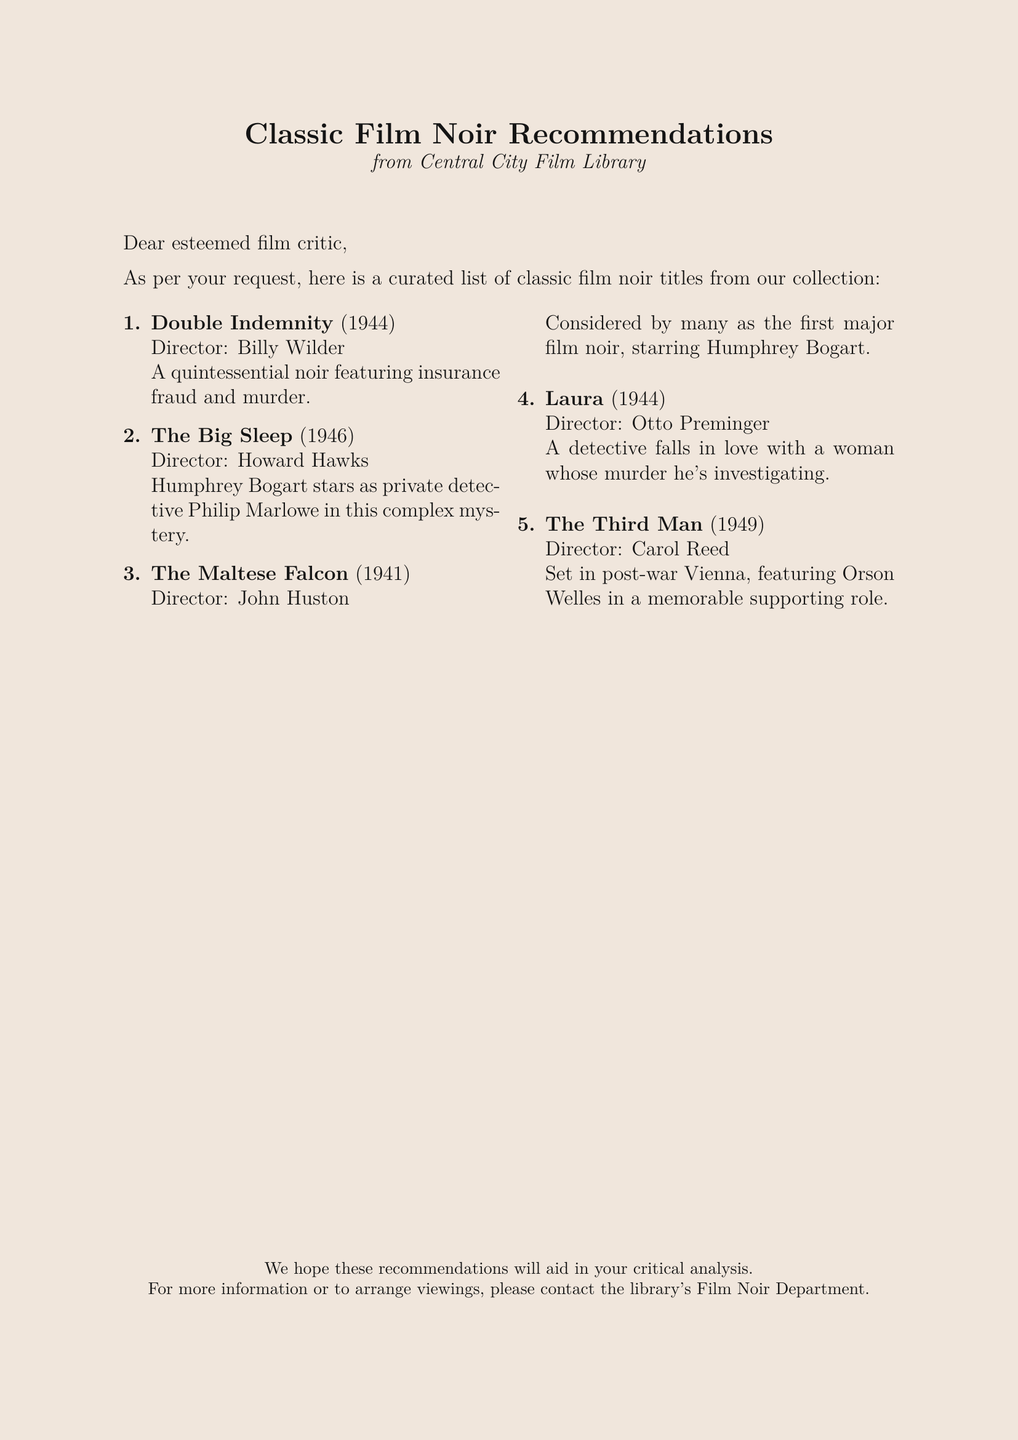What is the title of the first film recommended? The first film listed is "Double Indemnity."
Answer: Double Indemnity Who directed "The Big Sleep"? "The Big Sleep" was directed by Howard Hawks.
Answer: Howard Hawks In what year was "The Maltese Falcon" released? "The Maltese Falcon" was released in 1941.
Answer: 1941 Which film features a character investigating a murder he is in love with? "Laura" involves a detective falling in love with a woman whose murder he's investigating.
Answer: Laura How many films are listed in total? The document provides a list of five recommended films.
Answer: 5 Which film is set in post-war Vienna? "The Third Man" is the film set in post-war Vienna.
Answer: The Third Man What genre do these recommended films belong to? All the recommended films belong to the film noir genre.
Answer: film noir What is the name of the library providing these recommendations? The recommendations are from the Central City Film Library.
Answer: Central City Film Library Who is the star of "The Maltese Falcon"? The star of "The Maltese Falcon" is Humphrey Bogart.
Answer: Humphrey Bogart 